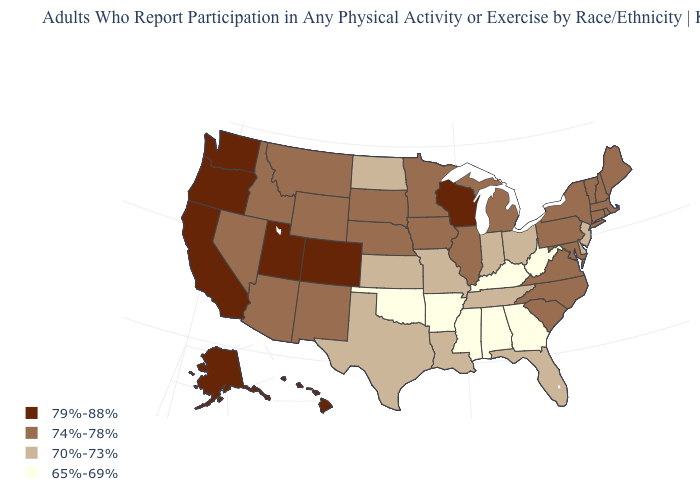Does California have the highest value in the West?
Be succinct. Yes. Name the states that have a value in the range 70%-73%?
Quick response, please. Delaware, Florida, Indiana, Kansas, Louisiana, Missouri, New Jersey, North Dakota, Ohio, Tennessee, Texas. Which states hav the highest value in the MidWest?
Give a very brief answer. Wisconsin. Does Kentucky have a higher value than Mississippi?
Answer briefly. No. What is the highest value in the USA?
Be succinct. 79%-88%. Does New Jersey have a lower value than West Virginia?
Answer briefly. No. How many symbols are there in the legend?
Concise answer only. 4. Name the states that have a value in the range 70%-73%?
Write a very short answer. Delaware, Florida, Indiana, Kansas, Louisiana, Missouri, New Jersey, North Dakota, Ohio, Tennessee, Texas. Is the legend a continuous bar?
Short answer required. No. What is the value of Arkansas?
Give a very brief answer. 65%-69%. What is the highest value in the USA?
Write a very short answer. 79%-88%. What is the value of Arizona?
Short answer required. 74%-78%. Name the states that have a value in the range 65%-69%?
Short answer required. Alabama, Arkansas, Georgia, Kentucky, Mississippi, Oklahoma, West Virginia. Does Connecticut have the highest value in the Northeast?
Concise answer only. Yes. 